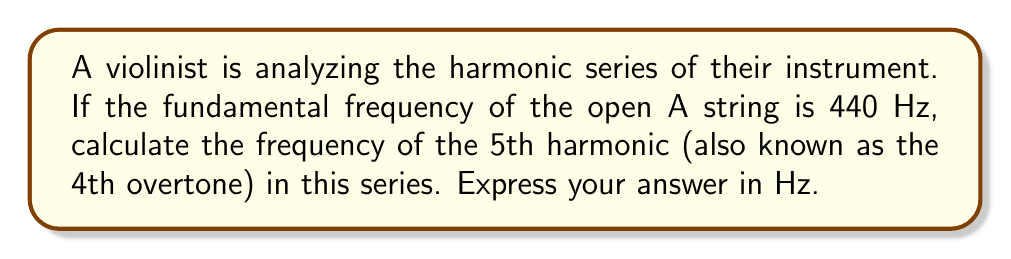Can you solve this math problem? To solve this problem, let's follow these steps:

1) The harmonic series is a sequence of frequencies that are integer multiples of the fundamental frequency. In mathematical terms, for a fundamental frequency $f$, the nth harmonic is given by:

   $$f_n = nf$$

   where $n$ is a positive integer.

2) In this case, we're given that the fundamental frequency (1st harmonic) is 440 Hz. So, $f = 440$ Hz.

3) We're asked to find the 5th harmonic. This means $n = 5$.

4) Let's substitute these values into our equation:

   $$f_5 = 5f = 5 * 440\text{ Hz}$$

5) Now, let's perform the multiplication:

   $$f_5 = 2200\text{ Hz}$$

6) It's worth noting that this frequency corresponds to the note C♯6 (C-sharp in the 6th octave), which is indeed the 5th harmonic of A4 (440 Hz).

This calculation demonstrates how the harmonic series relates to overtones in musical instruments. Each harmonic corresponds to an overtone, with the fundamental frequency being the 1st harmonic (or the 0th overtone), and each subsequent harmonic being the next overtone.
Answer: 2200 Hz 